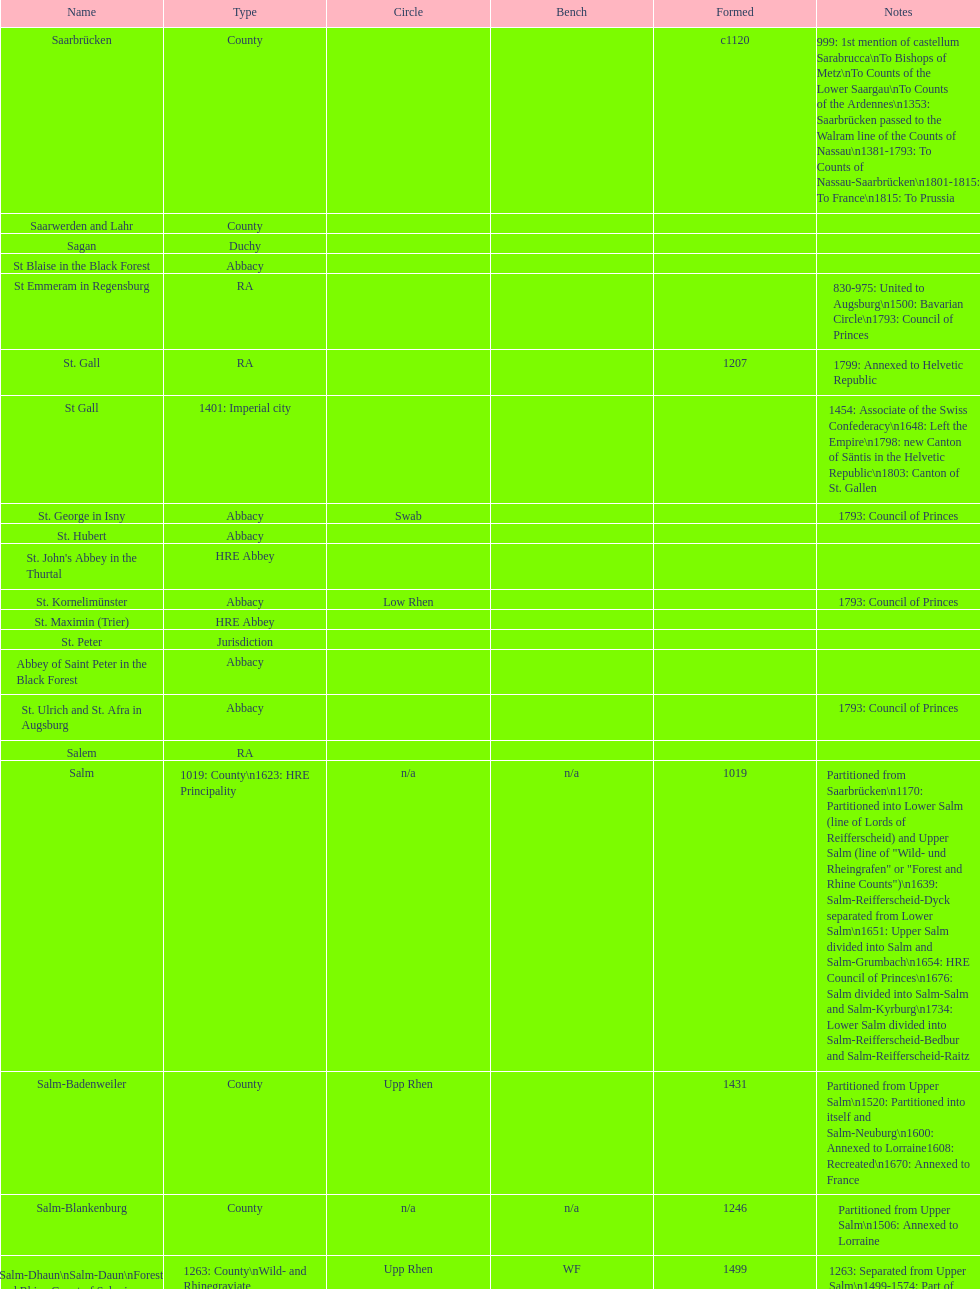How many states were of the same type as stuhlingen? 3. 